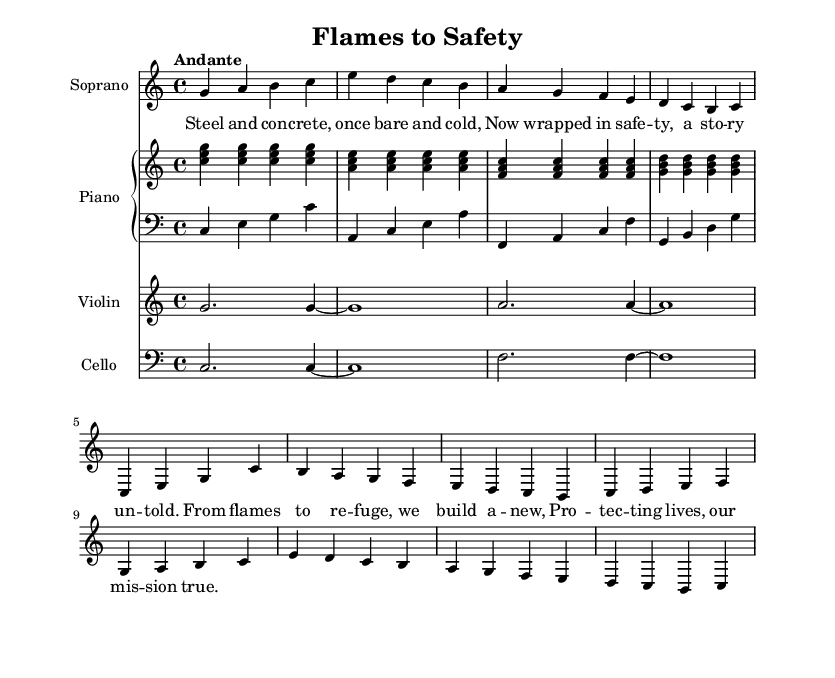What is the key signature of this music? The key signature is C major, which has no sharps or flats indicated at the beginning of the staff.
Answer: C major What is the time signature of the piece? The time signature is indicated by the 4/4 marker at the beginning of the score, showing that there are four beats in each measure.
Answer: 4/4 What is the tempo marking for the piece? The tempo marking at the beginning is "Andante," which indicates a moderately slow tempo.
Answer: Andante Which instrument accompanies the soprano in this piece? The piano accompanies the soprano, as shown by the PianoStaff beneath the soprano line.
Answer: Piano How many verses are sung in the soprano part? There is one verse provided in the soprano part, followed by a chorus. This can be seen in the lyrics section corresponding to the soprano melody.
Answer: One verse What is the primary theme represented in the lyrics? The primary theme centers around the transformation and safety of urban spaces, as suggested by the lyrics about protection and renewal.
Answer: Safety in urban transformation What vocal range is indicated for the soprano part? The soprano part is written in a range that typically corresponds to a higher vocal range, starting from the note g'' relative to c' in the score.
Answer: Higher vocal range 